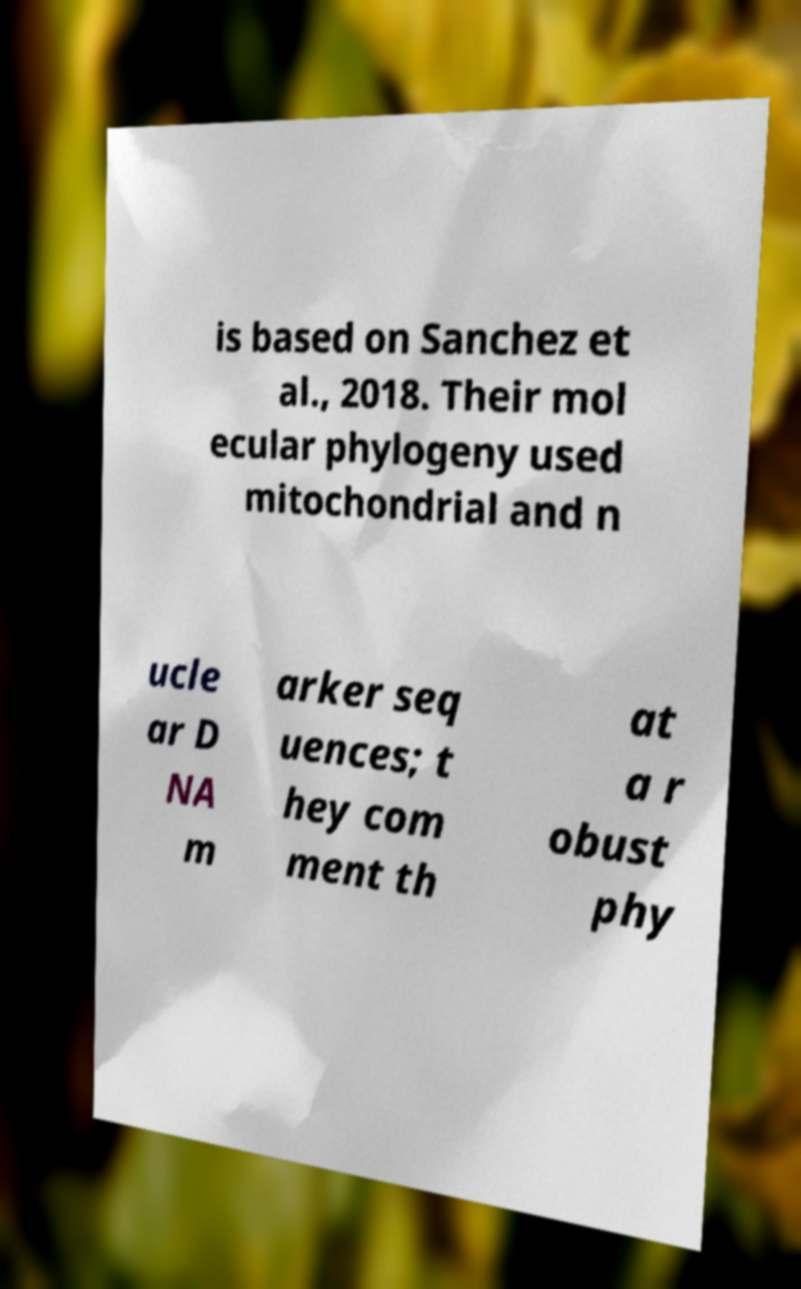Could you assist in decoding the text presented in this image and type it out clearly? is based on Sanchez et al., 2018. Their mol ecular phylogeny used mitochondrial and n ucle ar D NA m arker seq uences; t hey com ment th at a r obust phy 